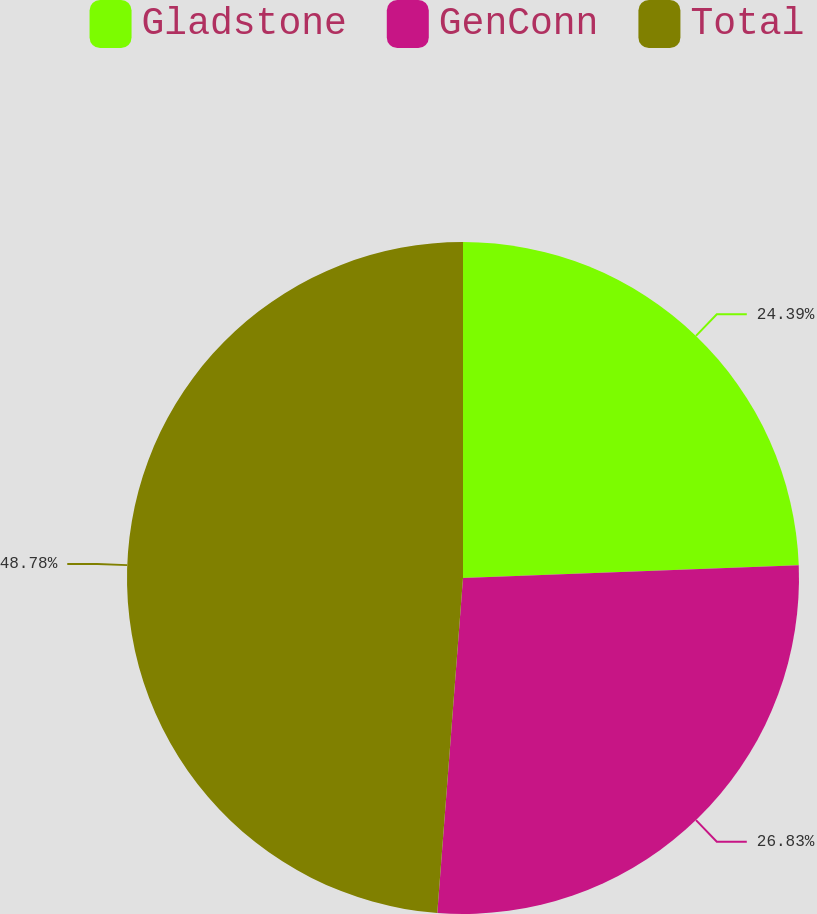Convert chart. <chart><loc_0><loc_0><loc_500><loc_500><pie_chart><fcel>Gladstone<fcel>GenConn<fcel>Total<nl><fcel>24.39%<fcel>26.83%<fcel>48.78%<nl></chart> 